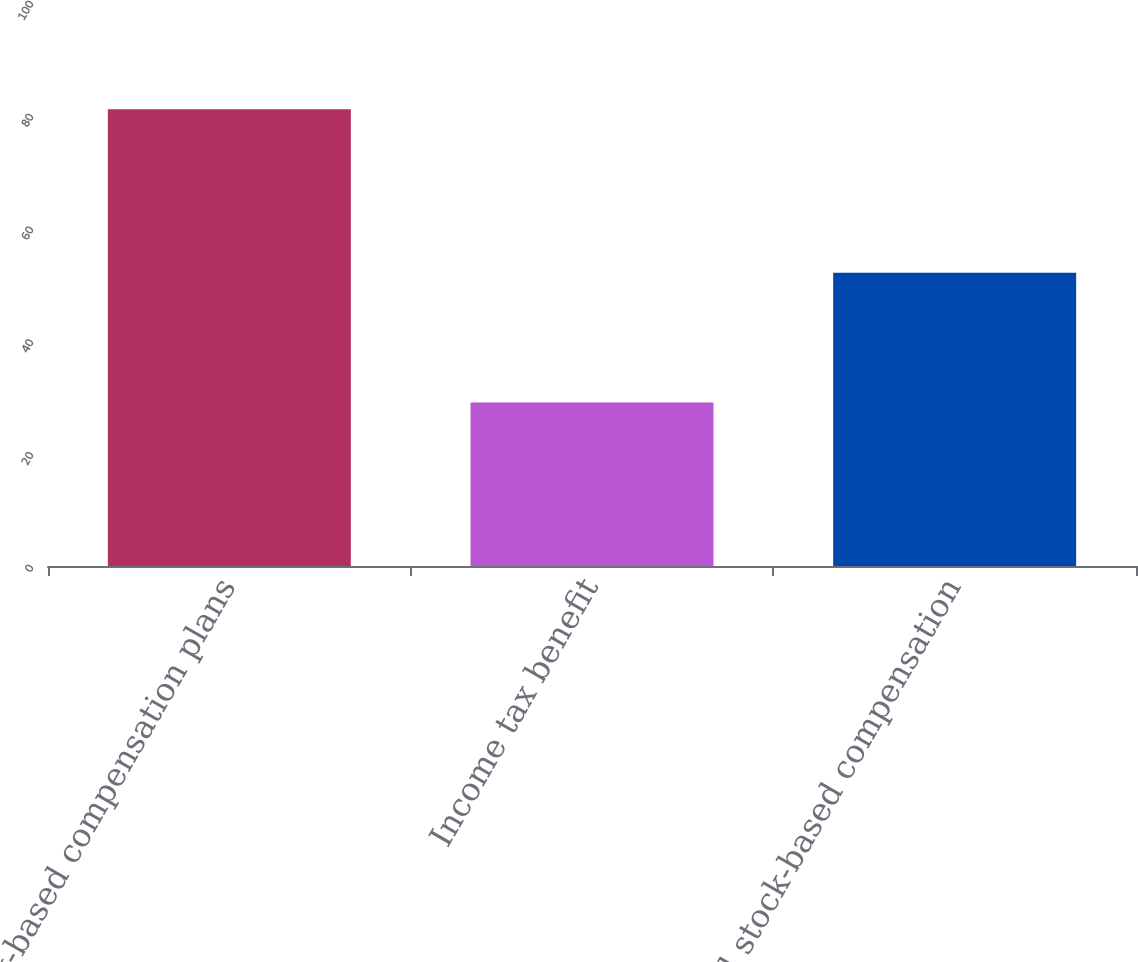Convert chart. <chart><loc_0><loc_0><loc_500><loc_500><bar_chart><fcel>Stock-based compensation plans<fcel>Income tax benefit<fcel>Total stock-based compensation<nl><fcel>81<fcel>29<fcel>52<nl></chart> 